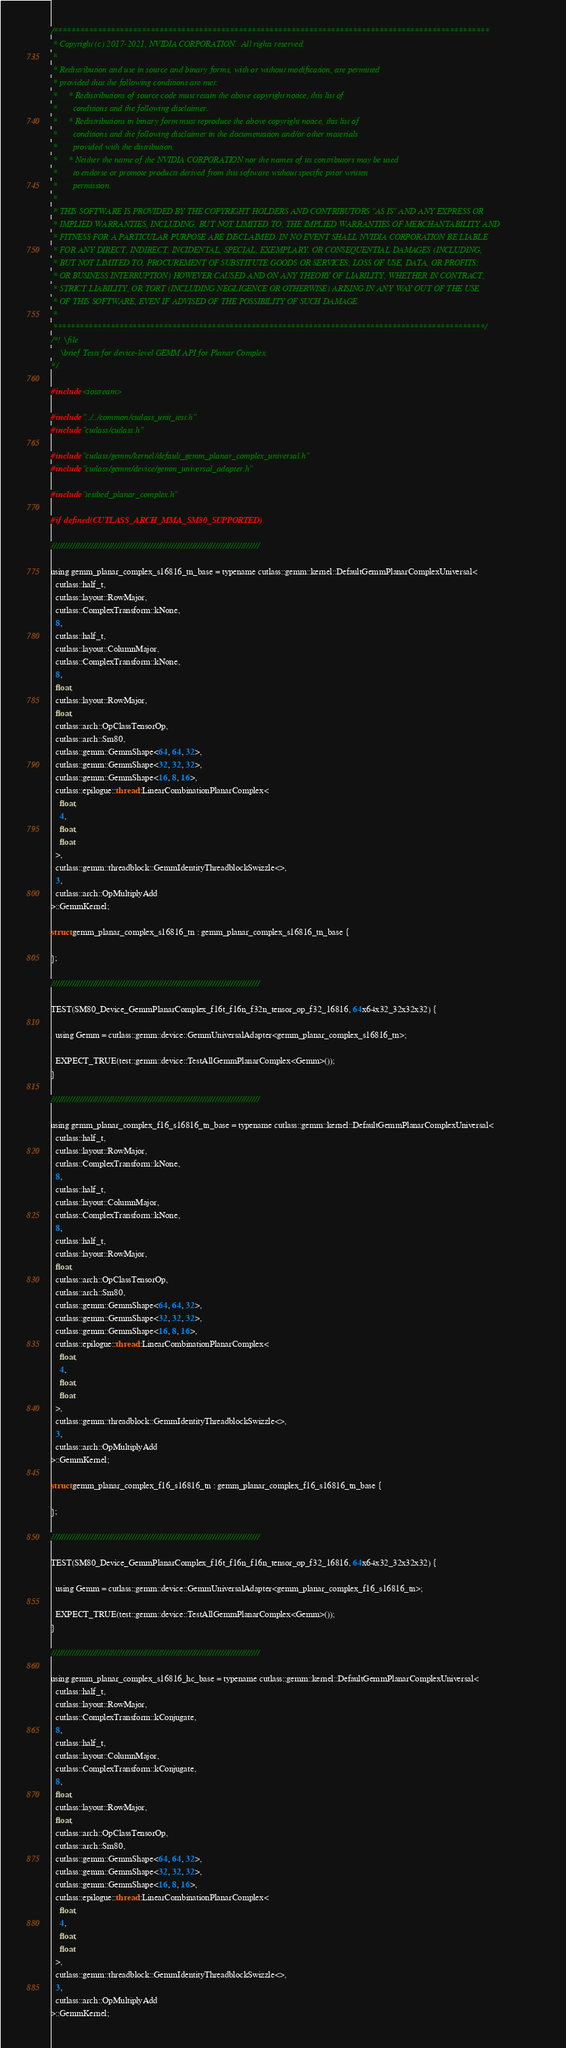<code> <loc_0><loc_0><loc_500><loc_500><_Cuda_>/***************************************************************************************************
 * Copyright (c) 2017-2021, NVIDIA CORPORATION.  All rights reserved.
 *
 * Redistribution and use in source and binary forms, with or without modification, are permitted
 * provided that the following conditions are met:
 *     * Redistributions of source code must retain the above copyright notice, this list of
 *       conditions and the following disclaimer.
 *     * Redistributions in binary form must reproduce the above copyright notice, this list of
 *       conditions and the following disclaimer in the documentation and/or other materials
 *       provided with the distribution.
 *     * Neither the name of the NVIDIA CORPORATION nor the names of its contributors may be used
 *       to endorse or promote products derived from this software without specific prior written
 *       permission.
 *
 * THIS SOFTWARE IS PROVIDED BY THE COPYRIGHT HOLDERS AND CONTRIBUTORS "AS IS" AND ANY EXPRESS OR
 * IMPLIED WARRANTIES, INCLUDING, BUT NOT LIMITED TO, THE IMPLIED WARRANTIES OF MERCHANTABILITY AND
 * FITNESS FOR A PARTICULAR PURPOSE ARE DISCLAIMED. IN NO EVENT SHALL NVIDIA CORPORATION BE LIABLE
 * FOR ANY DIRECT, INDIRECT, INCIDENTAL, SPECIAL, EXEMPLARY, OR CONSEQUENTIAL DAMAGES (INCLUDING,
 * BUT NOT LIMITED TO, PROCUREMENT OF SUBSTITUTE GOODS OR SERVICES; LOSS OF USE, DATA, OR PROFITS;
 * OR BUSINESS INTERRUPTION) HOWEVER CAUSED AND ON ANY THEORY OF LIABILITY, WHETHER IN CONTRACT,
 * STRICT LIABILITY, OR TORT (INCLUDING NEGLIGENCE OR OTHERWISE) ARISING IN ANY WAY OUT OF THE USE
 * OF THIS SOFTWARE, EVEN IF ADVISED OF THE POSSIBILITY OF SUCH DAMAGE.
 *
 **************************************************************************************************/
/*! \file
    \brief Tests for device-level GEMM API for Planar Complex.
*/

#include <iostream>

#include "../../common/cutlass_unit_test.h"
#include "cutlass/cutlass.h"

#include "cutlass/gemm/kernel/default_gemm_planar_complex_universal.h"
#include "cutlass/gemm/device/gemm_universal_adapter.h"

#include "testbed_planar_complex.h"

#if defined(CUTLASS_ARCH_MMA_SM80_SUPPORTED)

////////////////////////////////////////////////////////////////////////////////

using gemm_planar_complex_s16816_tn_base = typename cutlass::gemm::kernel::DefaultGemmPlanarComplexUniversal<
  cutlass::half_t,
  cutlass::layout::RowMajor,
  cutlass::ComplexTransform::kNone,
  8,
  cutlass::half_t,
  cutlass::layout::ColumnMajor,
  cutlass::ComplexTransform::kNone,
  8,
  float,
  cutlass::layout::RowMajor,
  float,
  cutlass::arch::OpClassTensorOp,
  cutlass::arch::Sm80,
  cutlass::gemm::GemmShape<64, 64, 32>,
  cutlass::gemm::GemmShape<32, 32, 32>,
  cutlass::gemm::GemmShape<16, 8, 16>,
  cutlass::epilogue::thread::LinearCombinationPlanarComplex<
    float,
    4,
    float,
    float
  >,
  cutlass::gemm::threadblock::GemmIdentityThreadblockSwizzle<>,
  3,
  cutlass::arch::OpMultiplyAdd
>::GemmKernel;

struct gemm_planar_complex_s16816_tn : gemm_planar_complex_s16816_tn_base {

};

////////////////////////////////////////////////////////////////////////////////

TEST(SM80_Device_GemmPlanarComplex_f16t_f16n_f32n_tensor_op_f32_16816, 64x64x32_32x32x32) {

  using Gemm = cutlass::gemm::device::GemmUniversalAdapter<gemm_planar_complex_s16816_tn>;

  EXPECT_TRUE(test::gemm::device::TestAllGemmPlanarComplex<Gemm>());
}

////////////////////////////////////////////////////////////////////////////////

using gemm_planar_complex_f16_s16816_tn_base = typename cutlass::gemm::kernel::DefaultGemmPlanarComplexUniversal<
  cutlass::half_t,
  cutlass::layout::RowMajor,
  cutlass::ComplexTransform::kNone,
  8,
  cutlass::half_t,
  cutlass::layout::ColumnMajor,
  cutlass::ComplexTransform::kNone,
  8,
  cutlass::half_t,
  cutlass::layout::RowMajor,
  float,
  cutlass::arch::OpClassTensorOp,
  cutlass::arch::Sm80,
  cutlass::gemm::GemmShape<64, 64, 32>,
  cutlass::gemm::GemmShape<32, 32, 32>,
  cutlass::gemm::GemmShape<16, 8, 16>,
  cutlass::epilogue::thread::LinearCombinationPlanarComplex<
    float,
    4,
    float,
    float
  >,
  cutlass::gemm::threadblock::GemmIdentityThreadblockSwizzle<>,
  3,
  cutlass::arch::OpMultiplyAdd
>::GemmKernel;

struct gemm_planar_complex_f16_s16816_tn : gemm_planar_complex_f16_s16816_tn_base {

};

////////////////////////////////////////////////////////////////////////////////

TEST(SM80_Device_GemmPlanarComplex_f16t_f16n_f16n_tensor_op_f32_16816, 64x64x32_32x32x32) {

  using Gemm = cutlass::gemm::device::GemmUniversalAdapter<gemm_planar_complex_f16_s16816_tn>;

  EXPECT_TRUE(test::gemm::device::TestAllGemmPlanarComplex<Gemm>());
}

////////////////////////////////////////////////////////////////////////////////

using gemm_planar_complex_s16816_hc_base = typename cutlass::gemm::kernel::DefaultGemmPlanarComplexUniversal<
  cutlass::half_t,
  cutlass::layout::RowMajor,
  cutlass::ComplexTransform::kConjugate,
  8,
  cutlass::half_t,
  cutlass::layout::ColumnMajor,
  cutlass::ComplexTransform::kConjugate,
  8,
  float,
  cutlass::layout::RowMajor,
  float,
  cutlass::arch::OpClassTensorOp,
  cutlass::arch::Sm80,
  cutlass::gemm::GemmShape<64, 64, 32>,
  cutlass::gemm::GemmShape<32, 32, 32>,
  cutlass::gemm::GemmShape<16, 8, 16>,
  cutlass::epilogue::thread::LinearCombinationPlanarComplex<
    float,
    4,
    float,
    float
  >,
  cutlass::gemm::threadblock::GemmIdentityThreadblockSwizzle<>,
  3,
  cutlass::arch::OpMultiplyAdd
>::GemmKernel;
</code> 